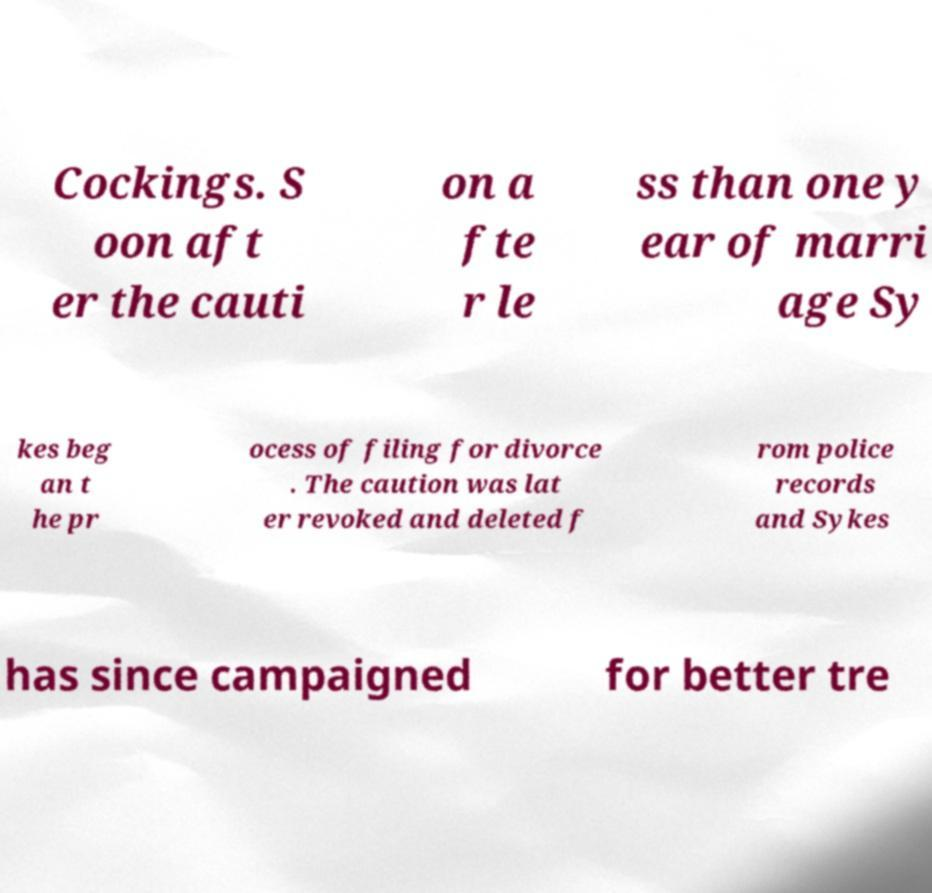What messages or text are displayed in this image? I need them in a readable, typed format. Cockings. S oon aft er the cauti on a fte r le ss than one y ear of marri age Sy kes beg an t he pr ocess of filing for divorce . The caution was lat er revoked and deleted f rom police records and Sykes has since campaigned for better tre 